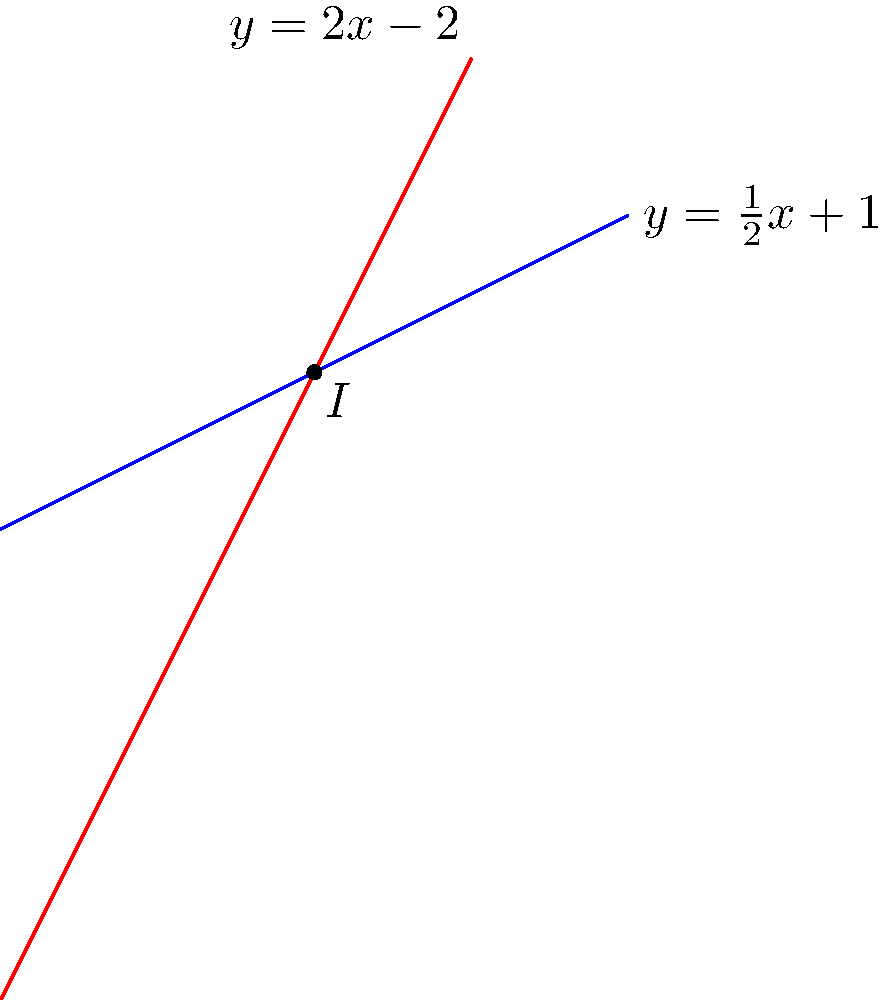As part of a digital archiving project for legal case locations, you need to determine the precise intersection point of two streets represented by linear equations. Given the equations $y = \frac{1}{2}x + 1$ and $y = 2x - 2$, find the coordinates of the intersection point $I$. To find the intersection point of two lines, we need to solve the system of equations:

1) $y = \frac{1}{2}x + 1$
2) $y = 2x - 2$

Step 1: Set the right-hand sides equal to each other:
$$\frac{1}{2}x + 1 = 2x - 2$$

Step 2: Subtract $\frac{1}{2}x$ from both sides:
$$1 = \frac{3}{2}x - 2$$

Step 3: Add 2 to both sides:
$$3 = \frac{3}{2}x$$

Step 4: Multiply both sides by $\frac{2}{3}$:
$$2 = x$$

Step 5: Substitute $x = 2$ into either of the original equations. Let's use $y = \frac{1}{2}x + 1$:
$$y = \frac{1}{2}(2) + 1 = 1 + 1 = 2$$

Therefore, the intersection point $I$ has coordinates $(2, 2)$.
Answer: $(2, 2)$ 